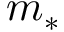Convert formula to latex. <formula><loc_0><loc_0><loc_500><loc_500>m _ { * }</formula> 